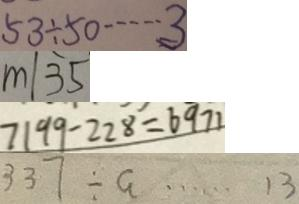<formula> <loc_0><loc_0><loc_500><loc_500>5 3 \div 5 0 \cdots 3 
 m \vert 3 5 
 7 1 9 9 - 2 2 8 = 6 9 7 1 
 3 3 7 \div a \cdots 1 3</formula> 